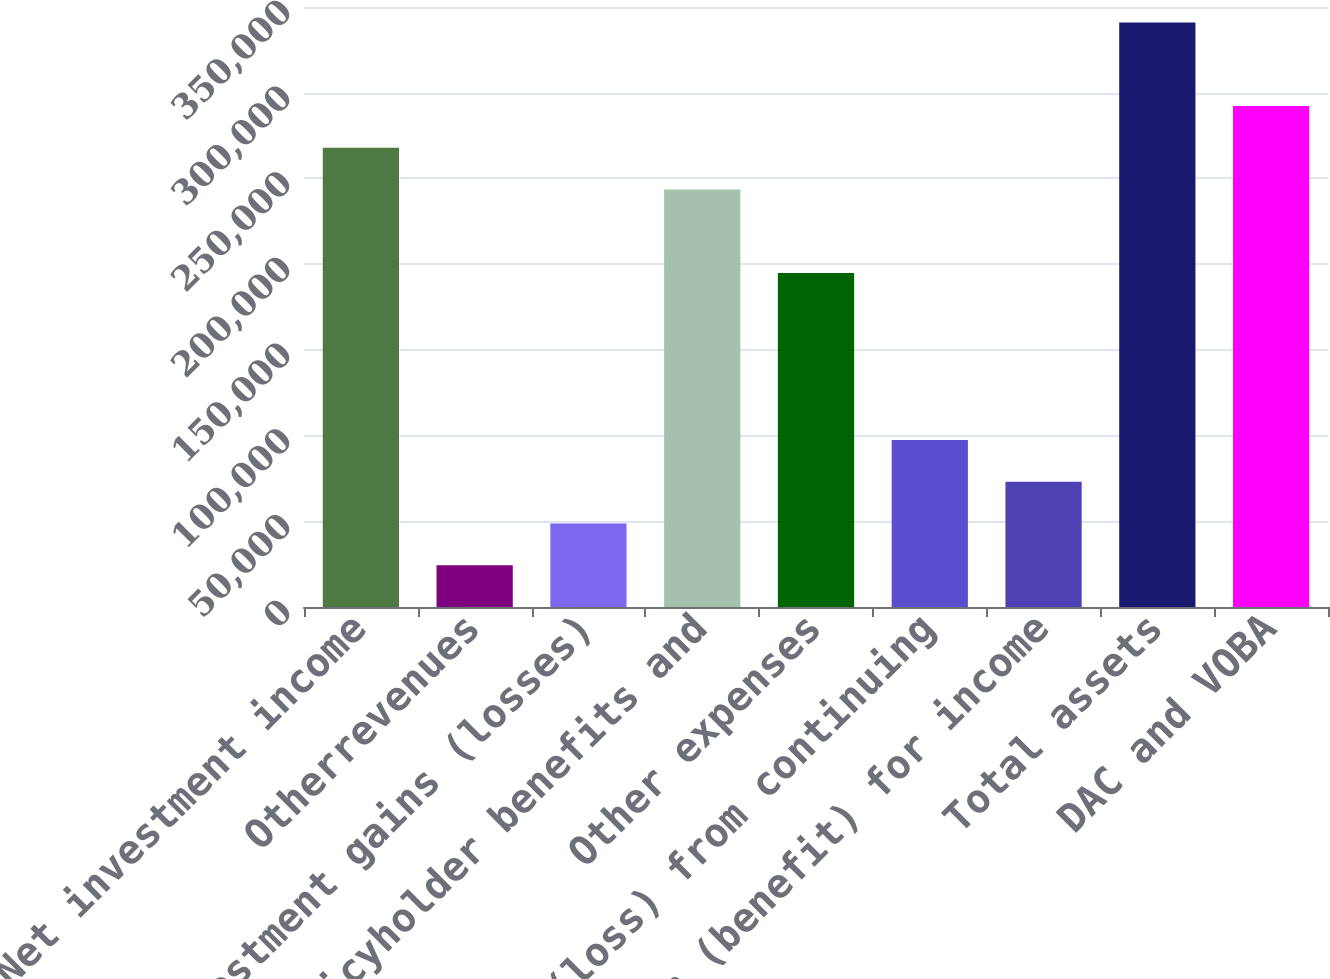Convert chart. <chart><loc_0><loc_0><loc_500><loc_500><bar_chart><fcel>Net investment income<fcel>Otherrevenues<fcel>Net investment gains (losses)<fcel>Policyholder benefits and<fcel>Other expenses<fcel>Income (loss) from continuing<fcel>Provision (benefit) for income<fcel>Total assets<fcel>DAC and VOBA<nl><fcel>267959<fcel>24405.4<fcel>48760.8<fcel>243604<fcel>194893<fcel>97471.6<fcel>73116.2<fcel>341026<fcel>292315<nl></chart> 